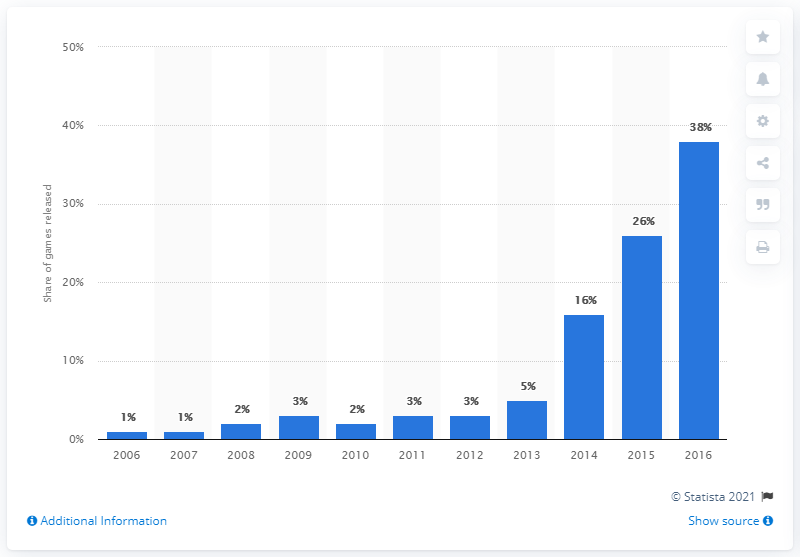Outline some significant characteristics in this image. Approximately 38% of the total number of games released on Steam in the measured period were made available in 2016. 